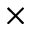Convert formula to latex. <formula><loc_0><loc_0><loc_500><loc_500>\times</formula> 